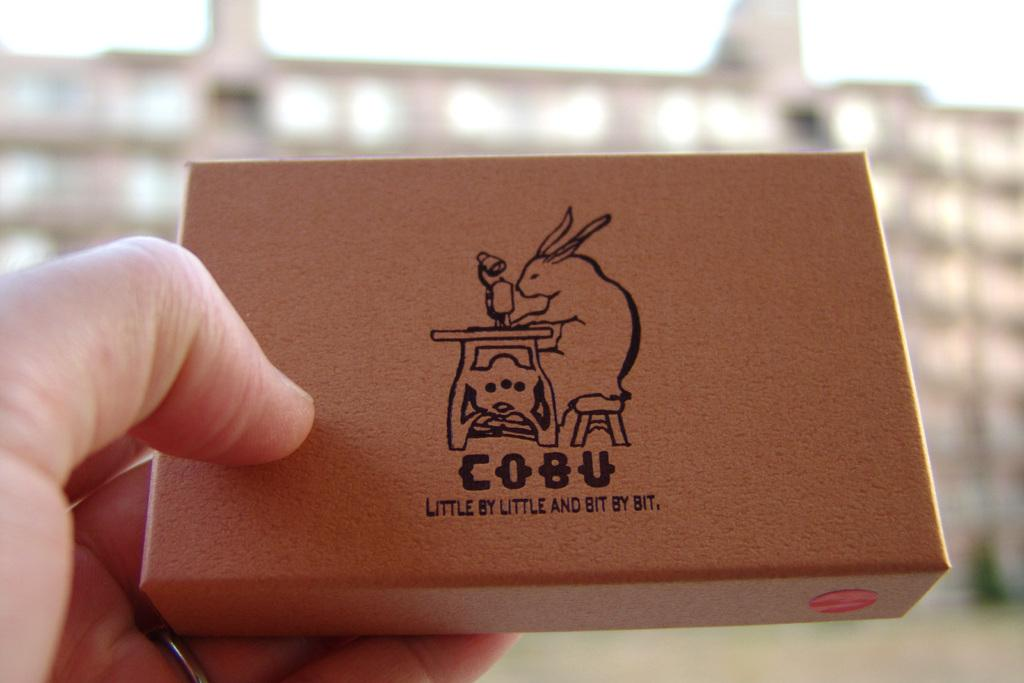What is the person in the image holding? The person is holding an object in the image. Can you describe the person's fingers in the image? The fingers of the person are visible in the image. What can be observed about the background of the image? The background of the image is blurred. What type of impulse can be seen affecting the soda in the image? There is no soda present in the image, and therefore no impulse affecting it. 